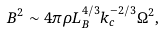Convert formula to latex. <formula><loc_0><loc_0><loc_500><loc_500>B ^ { 2 } \sim 4 \pi \rho L _ { B } ^ { 4 / 3 } k _ { c } ^ { - 2 / 3 } \Omega ^ { 2 } ,</formula> 